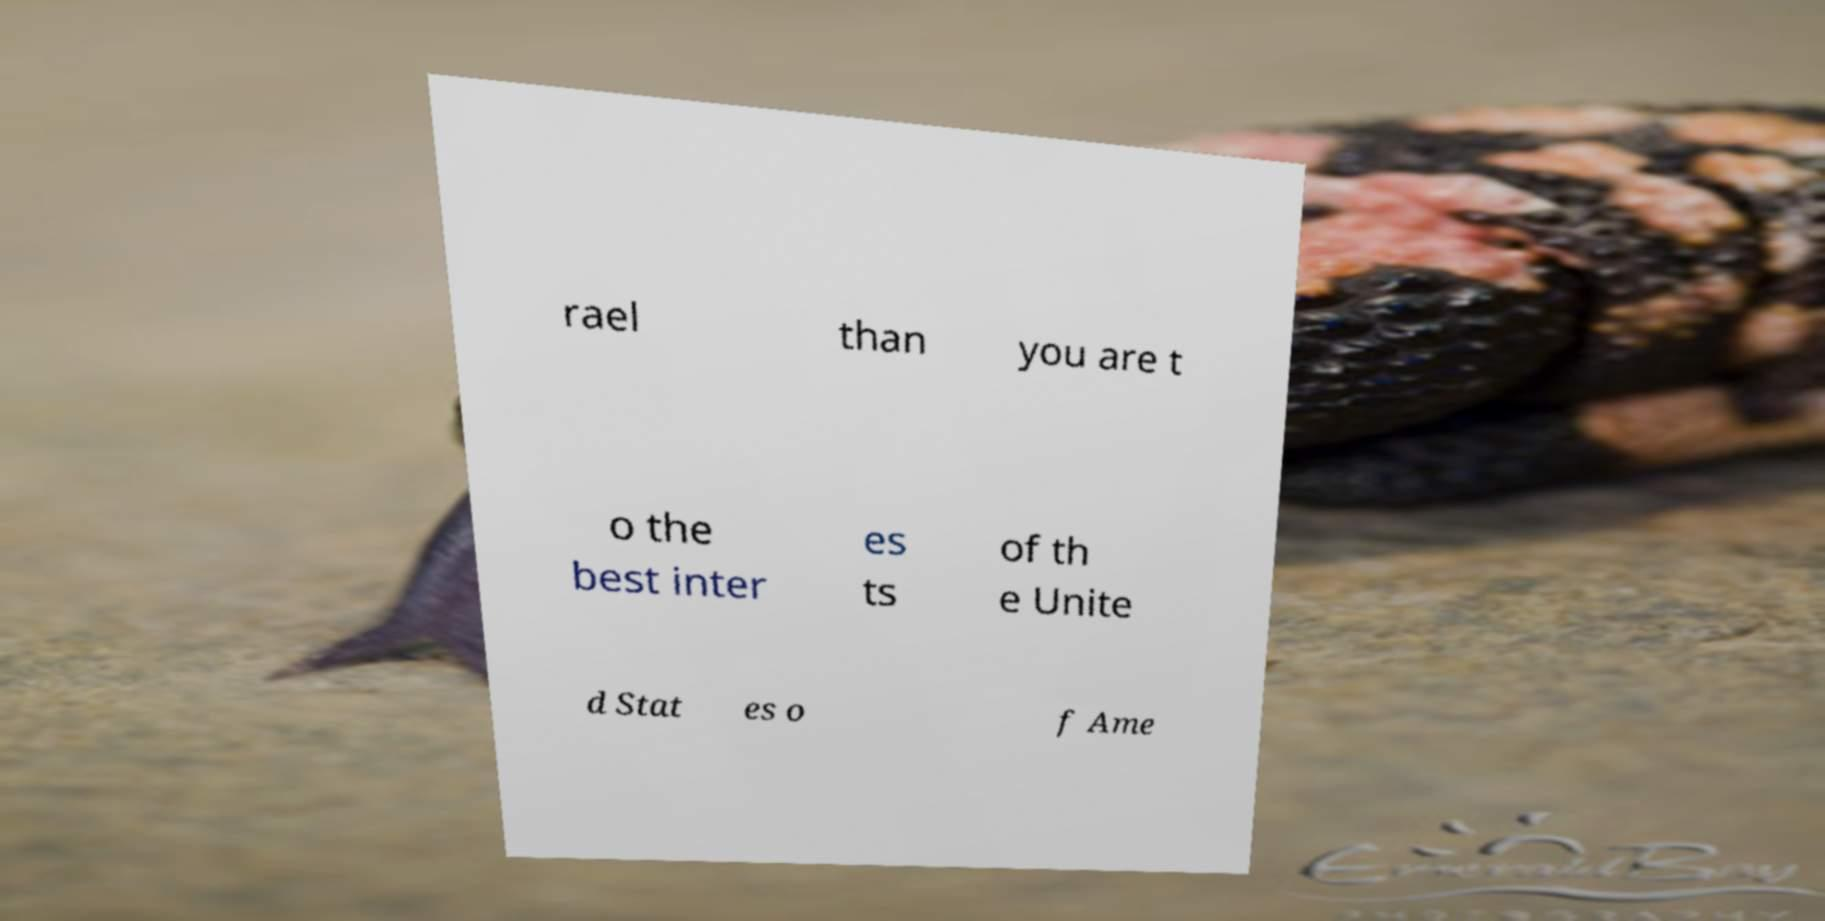Could you extract and type out the text from this image? rael than you are t o the best inter es ts of th e Unite d Stat es o f Ame 